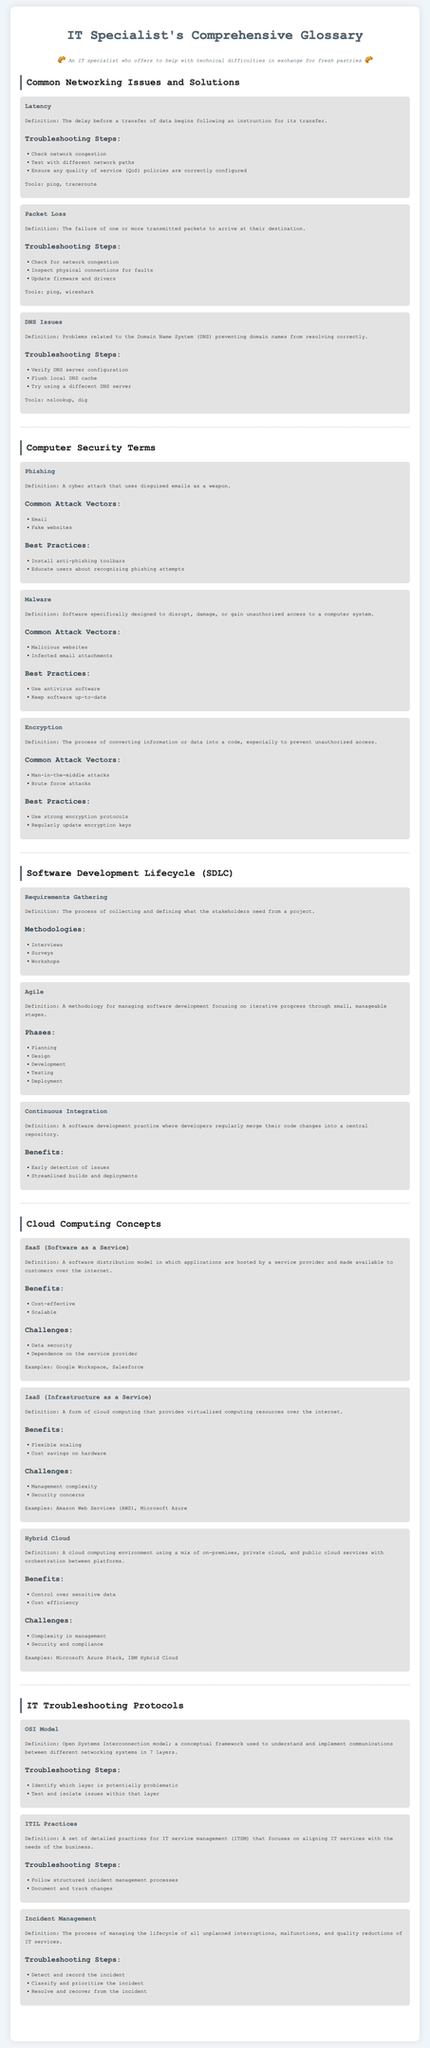what is the definition of latency? Latency is defined as the delay before a transfer of data begins following an instruction for its transfer.
Answer: delay before a transfer of data begins what are common attack vectors for malware? Common attack vectors for malware include malicious websites and infected email attachments.
Answer: malicious websites, infected email attachments what is the definition of SaaS? SaaS is defined as a software distribution model in which applications are hosted by a service provider and made available to customers over the internet.
Answer: software distribution model how many layers are in the OSI model? The OSI model consists of 7 layers.
Answer: 7 layers what is one benefit of continuous integration? One benefit of continuous integration is early detection of issues.
Answer: early detection of issues what should be checked for packet loss? To troubleshoot packet loss, one should check for network congestion.
Answer: network congestion what is a common practice to secure against phishing? A common practice to secure against phishing is to install anti-phishing toolbars.
Answer: install anti-phishing toolbars what is the purpose of requirements gathering? The purpose of requirements gathering is to collect and define what the stakeholders need from a project.
Answer: collect and define stakeholder needs what is a challenge of hybrid cloud? A challenge of hybrid cloud is complexity in management.
Answer: complexity in management 